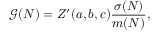Convert formula to latex. <formula><loc_0><loc_0><loc_500><loc_500>\mathcal { G } ( N ) = Z ^ { \prime } ( a , b , c ) \frac { \sigma ( N ) } { m ( N ) } ,</formula> 